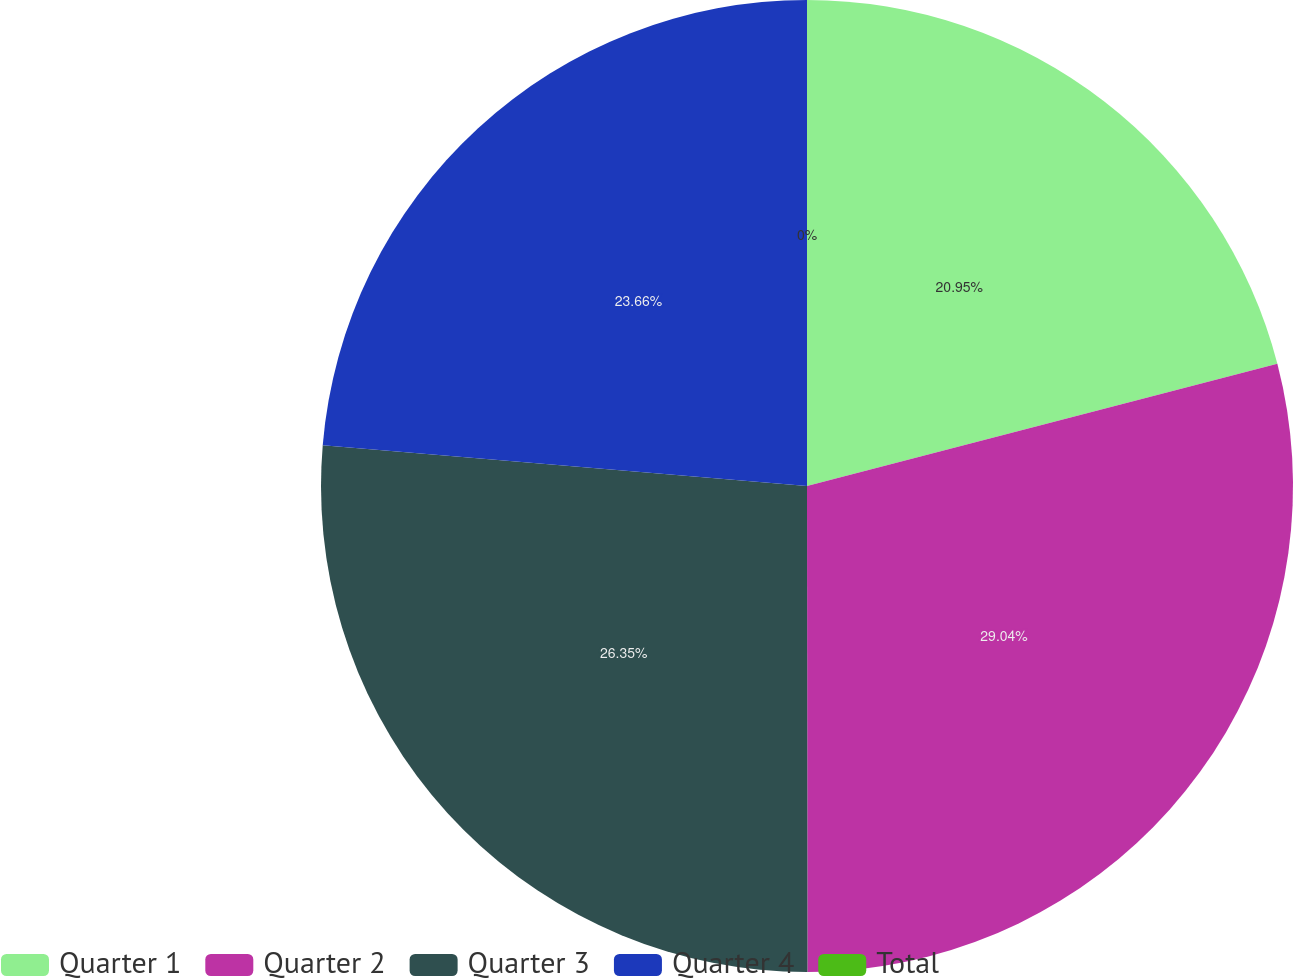Convert chart to OTSL. <chart><loc_0><loc_0><loc_500><loc_500><pie_chart><fcel>Quarter 1<fcel>Quarter 2<fcel>Quarter 3<fcel>Quarter 4<fcel>Total<nl><fcel>20.95%<fcel>29.03%<fcel>26.35%<fcel>23.66%<fcel>0.0%<nl></chart> 